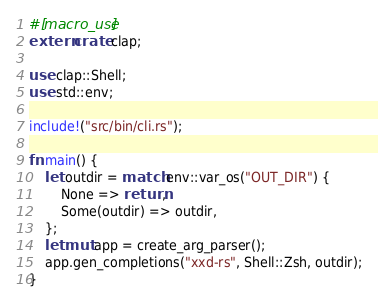Convert code to text. <code><loc_0><loc_0><loc_500><loc_500><_Rust_>#[macro_use]
extern crate clap;

use clap::Shell;
use std::env;

include!("src/bin/cli.rs");

fn main() {
    let outdir = match env::var_os("OUT_DIR") {
        None => return,
        Some(outdir) => outdir,
    };
    let mut app = create_arg_parser();
    app.gen_completions("xxd-rs", Shell::Zsh, outdir);
}
</code> 